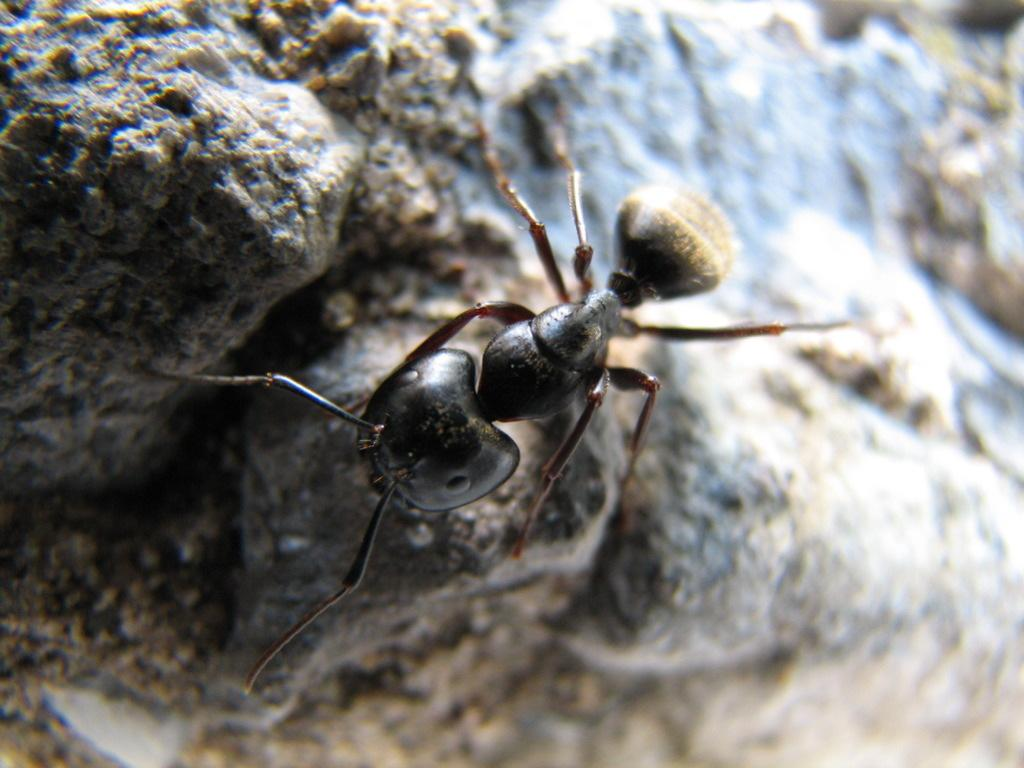What type of creature is in the image? There is an insect in the image. Where is the insect located? The insect is on a rock. What type of nut is being used as a kite anchor in the image? There is no nut or kite present in the image; it only features an insect on a rock. 